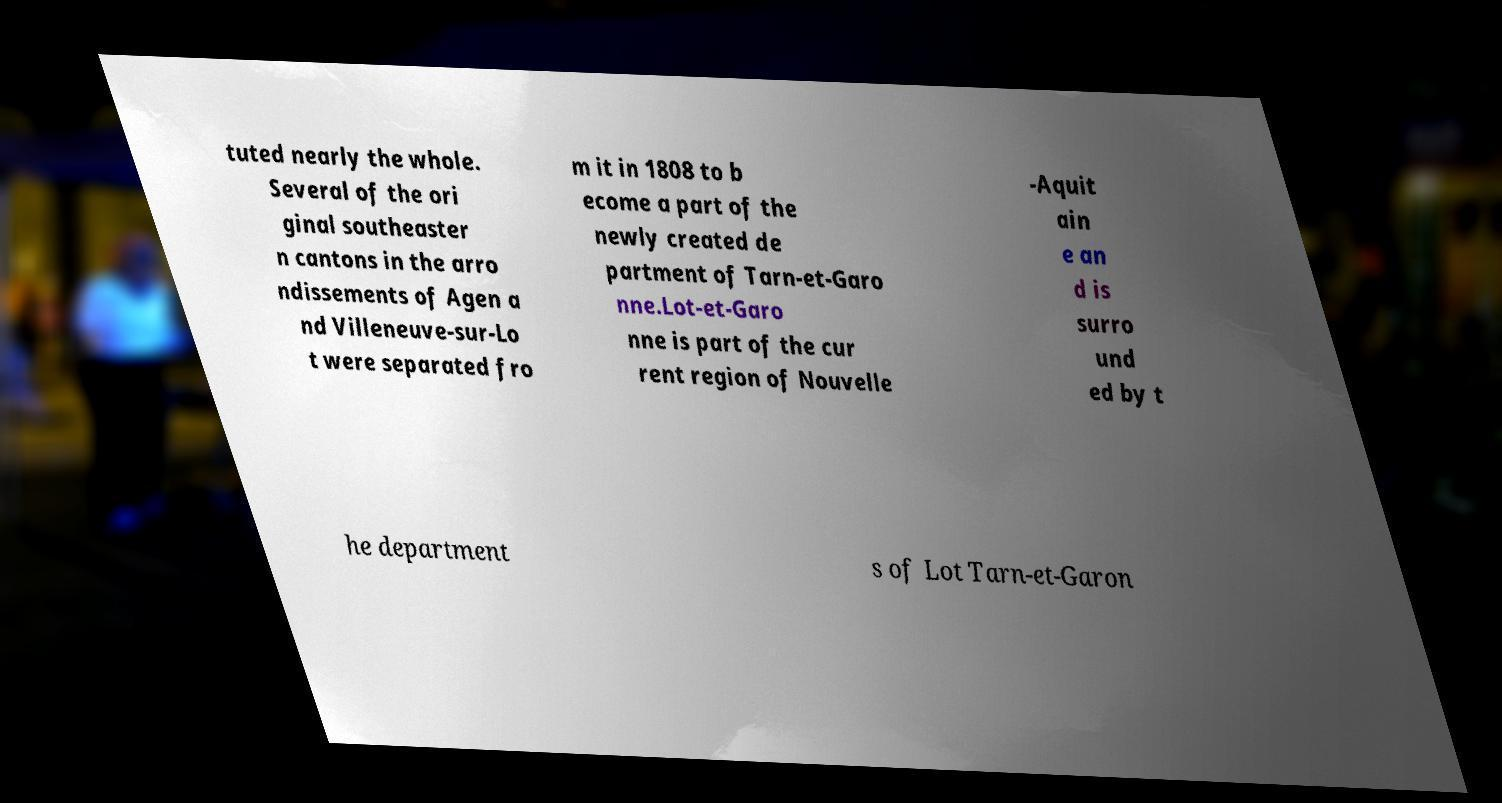For documentation purposes, I need the text within this image transcribed. Could you provide that? tuted nearly the whole. Several of the ori ginal southeaster n cantons in the arro ndissements of Agen a nd Villeneuve-sur-Lo t were separated fro m it in 1808 to b ecome a part of the newly created de partment of Tarn-et-Garo nne.Lot-et-Garo nne is part of the cur rent region of Nouvelle -Aquit ain e an d is surro und ed by t he department s of Lot Tarn-et-Garon 